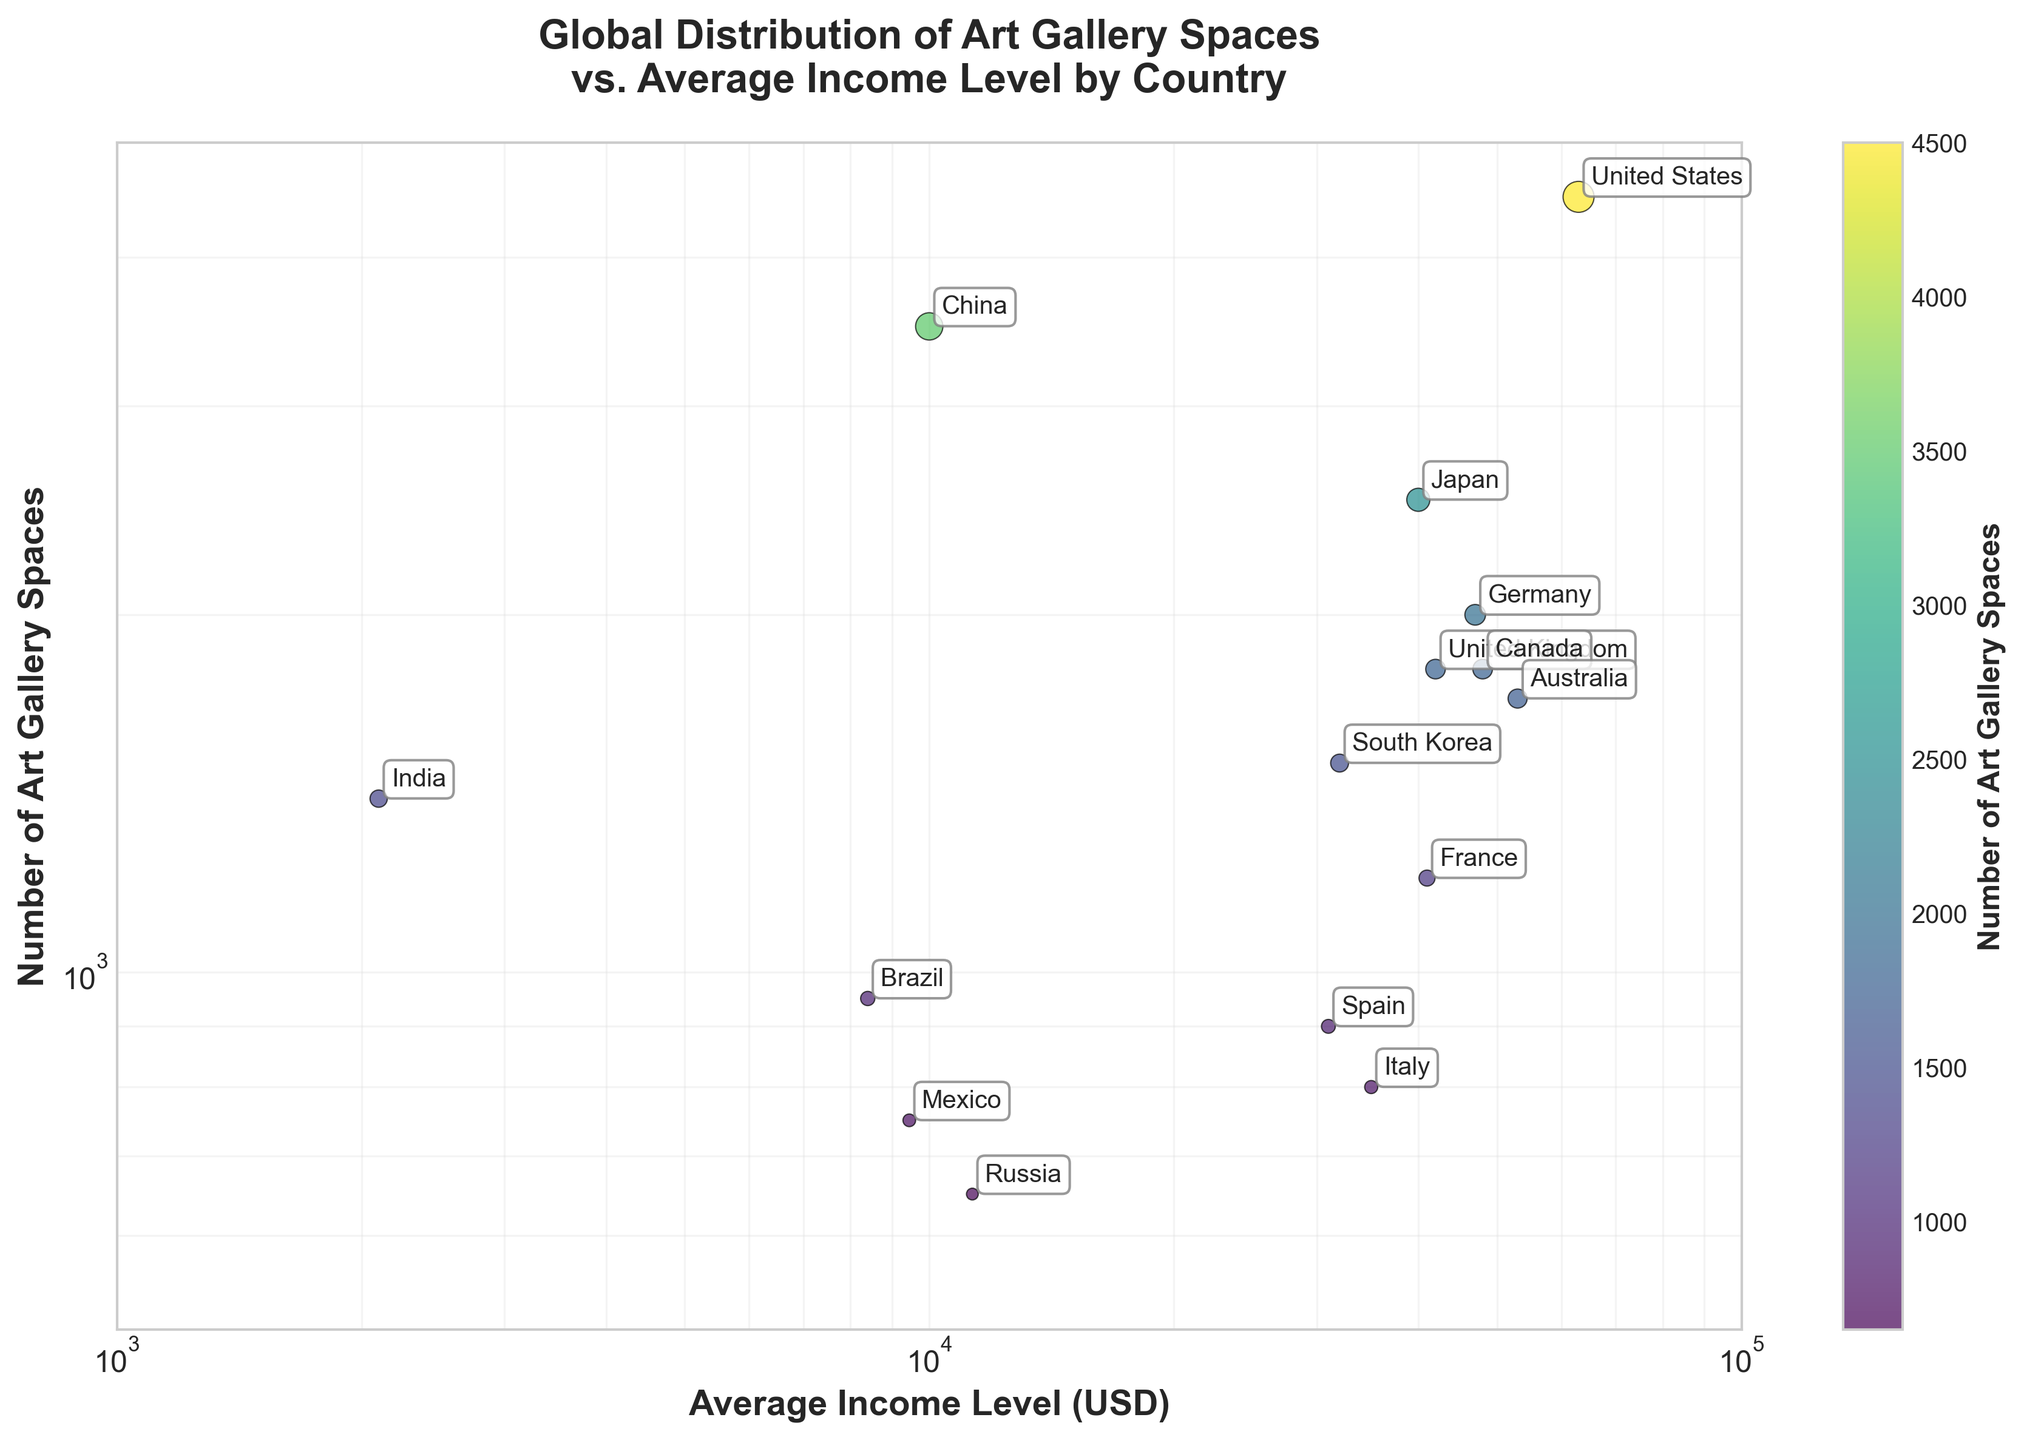What is the title of the figure? The title is typically located at the top of the figure. In this case, the title reads "Global Distribution of Art Gallery Spaces vs. Average Income Level by Country."
Answer: Global Distribution of Art Gallery Spaces vs. Average Income Level by Country How many countries are represented in the figure? Each country is represented by a data point (circle) on the scatter plot. By counting the data points or the annotations, you find that there are 15 countries listed.
Answer: 15 Which country has the highest number of art gallery spaces? By identifying the country with the highest value on the y-axis (number of art gallery spaces), we see that the United States has the highest number with 4500 spaces.
Answer: United States Is there any country with an average income level below $10,000 that has more than 1000 art gallery spaces? By checking the countries in the plot with an average income below $10,000 (x-axis) and ensuring their art gallery spaces (y-axis) are more than 1000, we identify China with 3500 art gallery spaces at $10,000 average income. India has 1400 gallery spaces but an average income much lower than $10,000.
Answer: India Which country has fewer art gallery spaces, Russia or Spain, and by how much? Locate Russia and Spain on the scatter plot and compare their y-values (art gallery spaces). Russia has 650 spaces and Spain has 900. The difference is 900 - 650.
Answer: Russia, by 250 spaces What is the color scale indicating? The color scale or color bar on the right side of the plot indicates the number of art gallery spaces, with the legend providing a gradient from lower to higher values.
Answer: Number of Art Gallery Spaces What relationship can be observed between average income level and the number of art gallery spaces in general? By observing the overall distribution of points on the scatter plot, it is generally noticed that countries with higher average incomes tend to have more art gallery spaces, although there are exceptions.
Answer: Higher income levels generally correlate with more art gallery spaces Which country has fewer art gallery spaces than Japan but more than South Korea? Locate Japan's y-value (2500) and South Korea's y-value (1500). The country with a y-value between these two is France with 1200 spaces.
Answer: France Are most of the countries with an average income level above $40,000 above or below 2000 art gallery spaces? Examine the countries that fall to the right of the $40,000 mark on the x-axis. Most of these countries (United States, Canada) are above 2000 art gallery spaces, except for Australia which is very close but still slightly below 2000.
Answer: Above What is the general trend in the relationship between art gallery spaces and average income level among the countries? When examining the scatter plot as a whole, we see that, although not strictly linear, there is a trend suggesting that countries with higher average income levels tend to have a greater number of art gallery spaces. This trend is visualized as a positive relationship between the two logarithmic axes.
Answer: Positive trend 